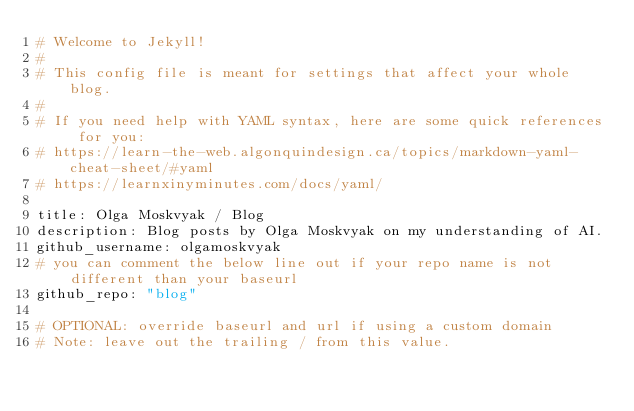<code> <loc_0><loc_0><loc_500><loc_500><_YAML_># Welcome to Jekyll!
#
# This config file is meant for settings that affect your whole blog.
#
# If you need help with YAML syntax, here are some quick references for you: 
# https://learn-the-web.algonquindesign.ca/topics/markdown-yaml-cheat-sheet/#yaml
# https://learnxinyminutes.com/docs/yaml/

title: Olga Moskvyak / Blog
description: Blog posts by Olga Moskvyak on my understanding of AI.
github_username: olgamoskvyak
# you can comment the below line out if your repo name is not different than your baseurl
github_repo: "blog"

# OPTIONAL: override baseurl and url if using a custom domain
# Note: leave out the trailing / from this value. </code> 